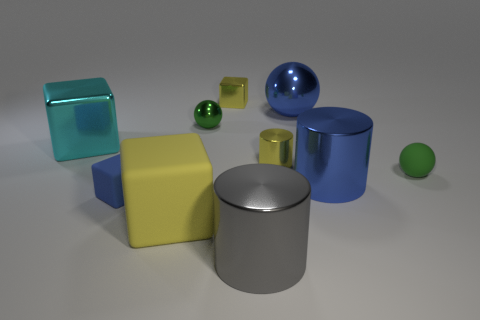Does the blue matte cube have the same size as the gray metal thing?
Provide a short and direct response. No. Are there more large blue metal cylinders than metal cylinders?
Your response must be concise. No. How many yellow matte objects are the same size as the cyan cube?
Your answer should be compact. 1. Do the small blue object and the green sphere right of the large blue cylinder have the same material?
Your answer should be compact. Yes. Are there fewer green metal objects than tiny gray blocks?
Your answer should be compact. No. Is there anything else that is the same color as the big metallic cube?
Offer a very short reply. No. What shape is the cyan object that is the same material as the big blue cylinder?
Provide a short and direct response. Cube. How many metal cylinders are behind the blue cylinder that is to the left of the small green matte thing that is behind the large blue cylinder?
Give a very brief answer. 1. What shape is the yellow object that is behind the large yellow object and in front of the tiny green metallic ball?
Your answer should be very brief. Cylinder. Are there fewer tiny metallic cylinders that are behind the big cyan cube than big gray metallic cylinders?
Offer a very short reply. Yes. 